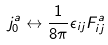<formula> <loc_0><loc_0><loc_500><loc_500>j ^ { a } _ { 0 } \leftrightarrow \frac { 1 } { 8 \pi } \epsilon _ { i j } F ^ { a } _ { i j }</formula> 